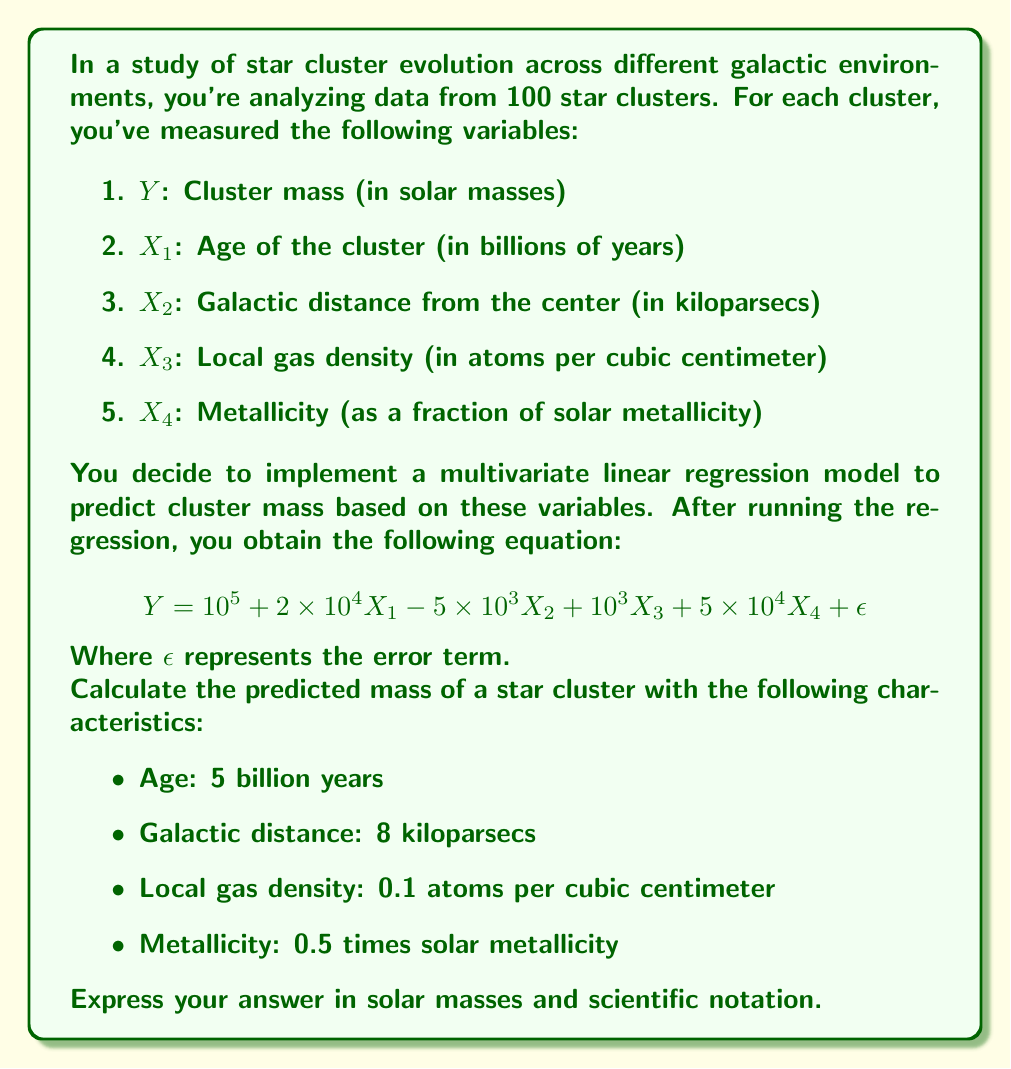Solve this math problem. To solve this problem, we need to substitute the given values into our multivariate linear regression equation. Let's go through this step-by-step:

1) Recall our equation:
   $$Y = 10^5 + 2 \times 10^4 X_1 - 5 \times 10^3 X_2 + 10^3 X_3 + 5 \times 10^4 X_4 + \epsilon$$

2) We're given the following values:
   $X_1 = 5$ (age in billions of years)
   $X_2 = 8$ (galactic distance in kiloparsecs)
   $X_3 = 0.1$ (local gas density in atoms per cubic centimeter)
   $X_4 = 0.5$ (metallicity as a fraction of solar metallicity)

3) Let's substitute these values into our equation:
   $$Y = 10^5 + 2 \times 10^4 (5) - 5 \times 10^3 (8) + 10^3 (0.1) + 5 \times 10^4 (0.5) + \epsilon$$

4) Now, let's calculate each term:
   - $10^5 = 100,000$
   - $2 \times 10^4 (5) = 100,000$
   - $-5 \times 10^3 (8) = -40,000$
   - $10^3 (0.1) = 100$
   - $5 \times 10^4 (0.5) = 25,000$

5) Adding these terms:
   $$Y = 100,000 + 100,000 - 40,000 + 100 + 25,000 + \epsilon$$
   $$Y = 185,100 + \epsilon$$

6) Since $\epsilon$ represents the error term and we're asked for the predicted mass, we can ignore it in our final calculation.

7) The result, 185,100 solar masses, can be expressed in scientific notation as $1.851 \times 10^5$ solar masses.
Answer: $1.851 \times 10^5$ solar masses 